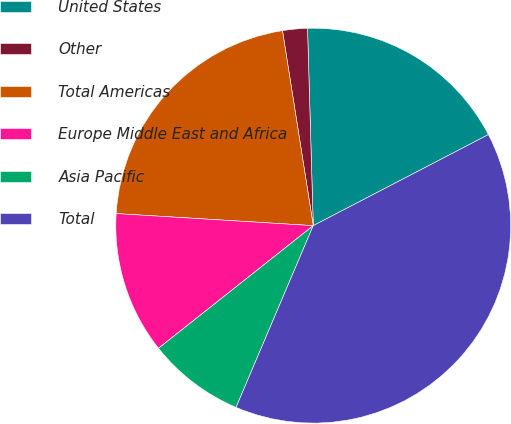Convert chart to OTSL. <chart><loc_0><loc_0><loc_500><loc_500><pie_chart><fcel>United States<fcel>Other<fcel>Total Americas<fcel>Europe Middle East and Africa<fcel>Asia Pacific<fcel>Total<nl><fcel>17.83%<fcel>2.03%<fcel>21.53%<fcel>11.64%<fcel>7.94%<fcel>39.02%<nl></chart> 